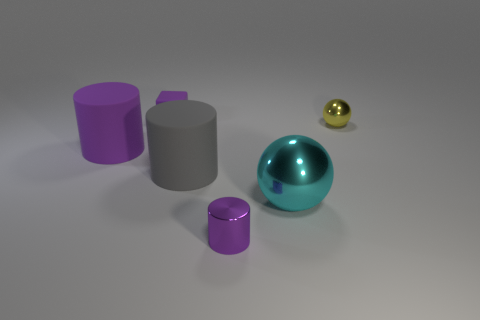The big ball is what color?
Give a very brief answer. Cyan. There is a large cylinder to the left of the small purple rubber object; is it the same color as the small metal cylinder?
Provide a short and direct response. Yes. There is a small cylinder that is the same color as the block; what material is it?
Your answer should be very brief. Metal. How many large matte cylinders have the same color as the shiny cylinder?
Your response must be concise. 1. There is a thing in front of the big cyan sphere; is its shape the same as the small yellow shiny thing?
Offer a terse response. No. Are there fewer tiny purple matte cubes on the right side of the small shiny sphere than metallic objects left of the cube?
Your answer should be very brief. No. There is a small purple object in front of the small sphere; what is it made of?
Provide a succinct answer. Metal. There is a rubber object that is the same color as the small matte cube; what size is it?
Give a very brief answer. Large. Is there a gray cube that has the same size as the yellow ball?
Ensure brevity in your answer.  No. Do the big cyan metallic object and the tiny purple object on the left side of the shiny cylinder have the same shape?
Ensure brevity in your answer.  No. 